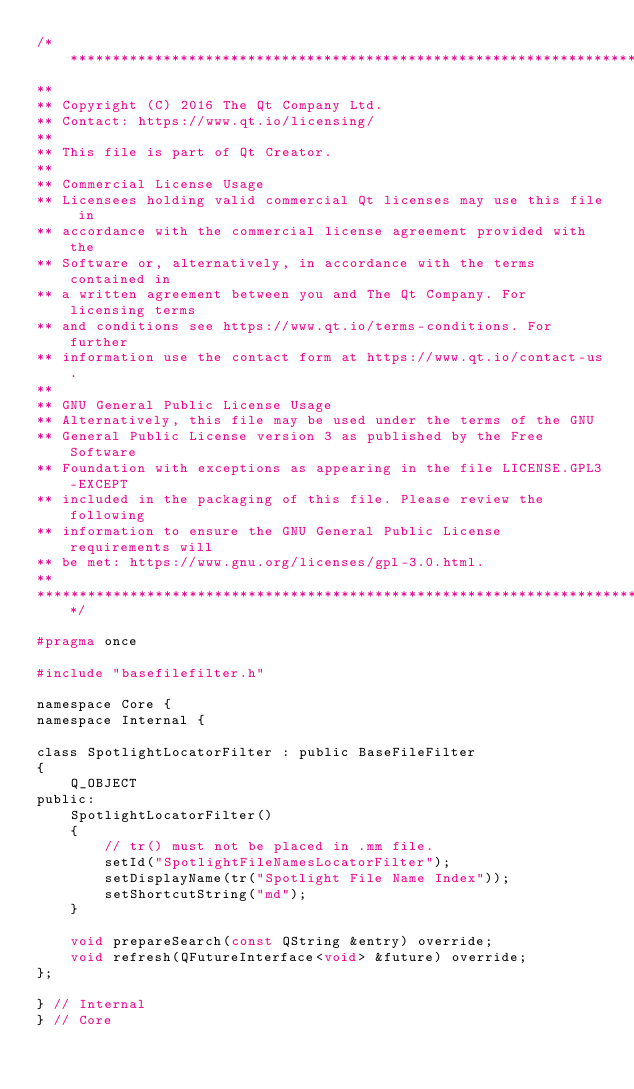<code> <loc_0><loc_0><loc_500><loc_500><_C_>/****************************************************************************
**
** Copyright (C) 2016 The Qt Company Ltd.
** Contact: https://www.qt.io/licensing/
**
** This file is part of Qt Creator.
**
** Commercial License Usage
** Licensees holding valid commercial Qt licenses may use this file in
** accordance with the commercial license agreement provided with the
** Software or, alternatively, in accordance with the terms contained in
** a written agreement between you and The Qt Company. For licensing terms
** and conditions see https://www.qt.io/terms-conditions. For further
** information use the contact form at https://www.qt.io/contact-us.
**
** GNU General Public License Usage
** Alternatively, this file may be used under the terms of the GNU
** General Public License version 3 as published by the Free Software
** Foundation with exceptions as appearing in the file LICENSE.GPL3-EXCEPT
** included in the packaging of this file. Please review the following
** information to ensure the GNU General Public License requirements will
** be met: https://www.gnu.org/licenses/gpl-3.0.html.
**
****************************************************************************/

#pragma once

#include "basefilefilter.h"

namespace Core {
namespace Internal {

class SpotlightLocatorFilter : public BaseFileFilter
{
    Q_OBJECT
public:
    SpotlightLocatorFilter()
    {
        // tr() must not be placed in .mm file.
        setId("SpotlightFileNamesLocatorFilter");
        setDisplayName(tr("Spotlight File Name Index"));
        setShortcutString("md");
    }

    void prepareSearch(const QString &entry) override;
    void refresh(QFutureInterface<void> &future) override;
};

} // Internal
} // Core
</code> 